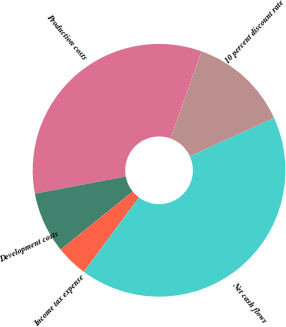<chart> <loc_0><loc_0><loc_500><loc_500><pie_chart><fcel>Production costs<fcel>Development costs<fcel>Income tax expense<fcel>Net cash flows<fcel>10 percent discount rate<nl><fcel>33.41%<fcel>7.84%<fcel>4.05%<fcel>41.95%<fcel>12.74%<nl></chart> 